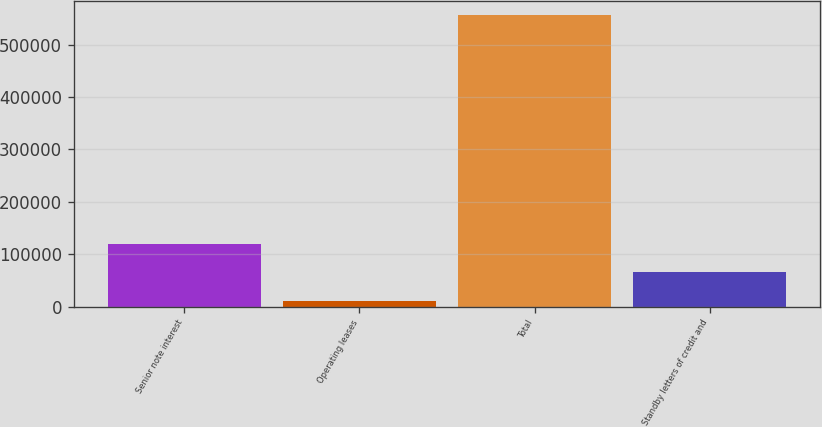Convert chart. <chart><loc_0><loc_0><loc_500><loc_500><bar_chart><fcel>Senior note interest<fcel>Operating leases<fcel>Total<fcel>Standby letters of credit and<nl><fcel>120033<fcel>11049<fcel>555971<fcel>65541.2<nl></chart> 